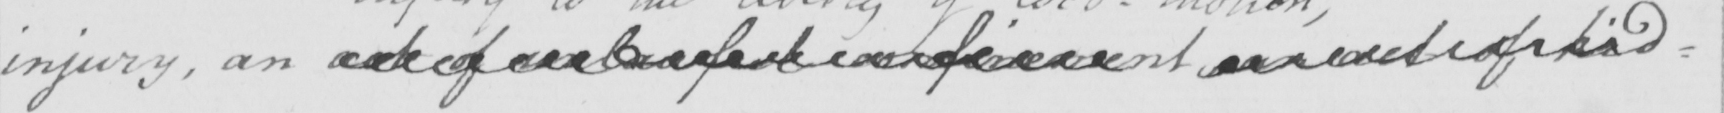What does this handwritten line say? injury , an act of unlawful  <gap/>  an act of kid= 